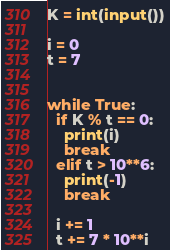<code> <loc_0><loc_0><loc_500><loc_500><_Python_>K = int(input())
 
i = 0
t = 7
 

while True:
  if K % t == 0: 
    print(i)
    break
  elif t > 10**6:
    print(-1)
    break
 
  i += 1  
  t += 7 * 10**i
</code> 